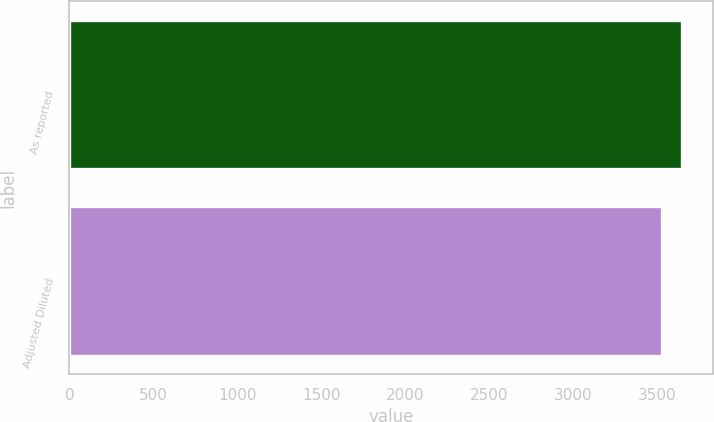<chart> <loc_0><loc_0><loc_500><loc_500><bar_chart><fcel>As reported<fcel>Adjusted Diluted<nl><fcel>3650<fcel>3528<nl></chart> 